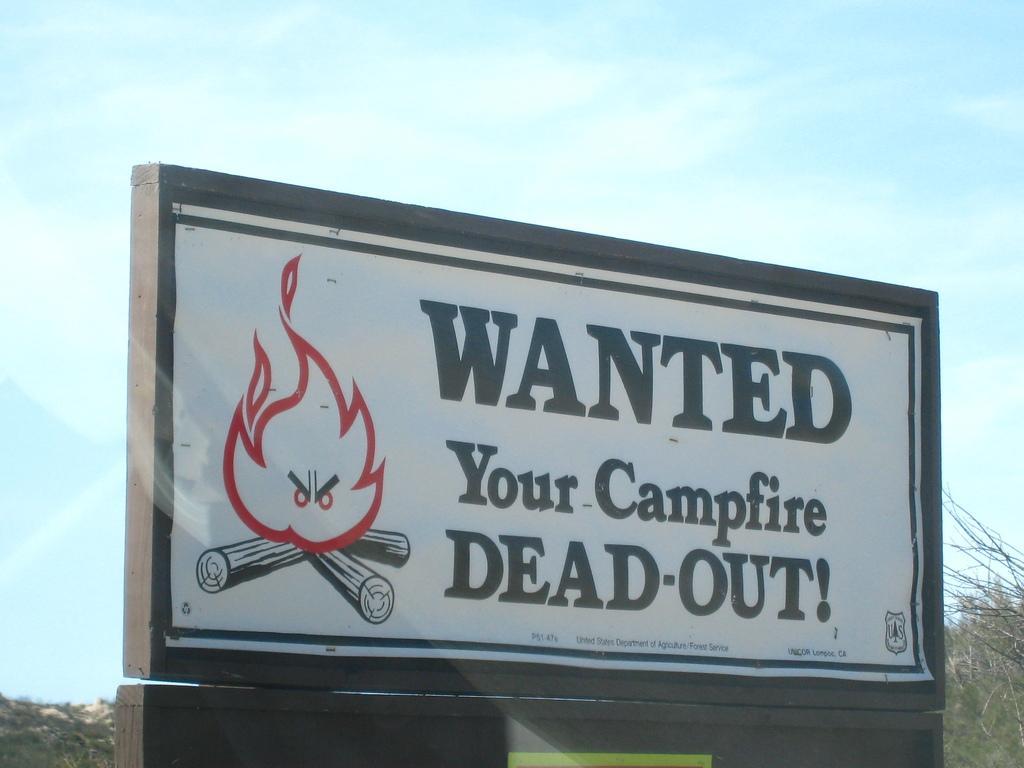In one or two sentences, can you explain what this image depicts? In the foreground of this image, there is board with text written on it as" Wanted your camp fire dead out!". In the background, there are trees and the sky. 